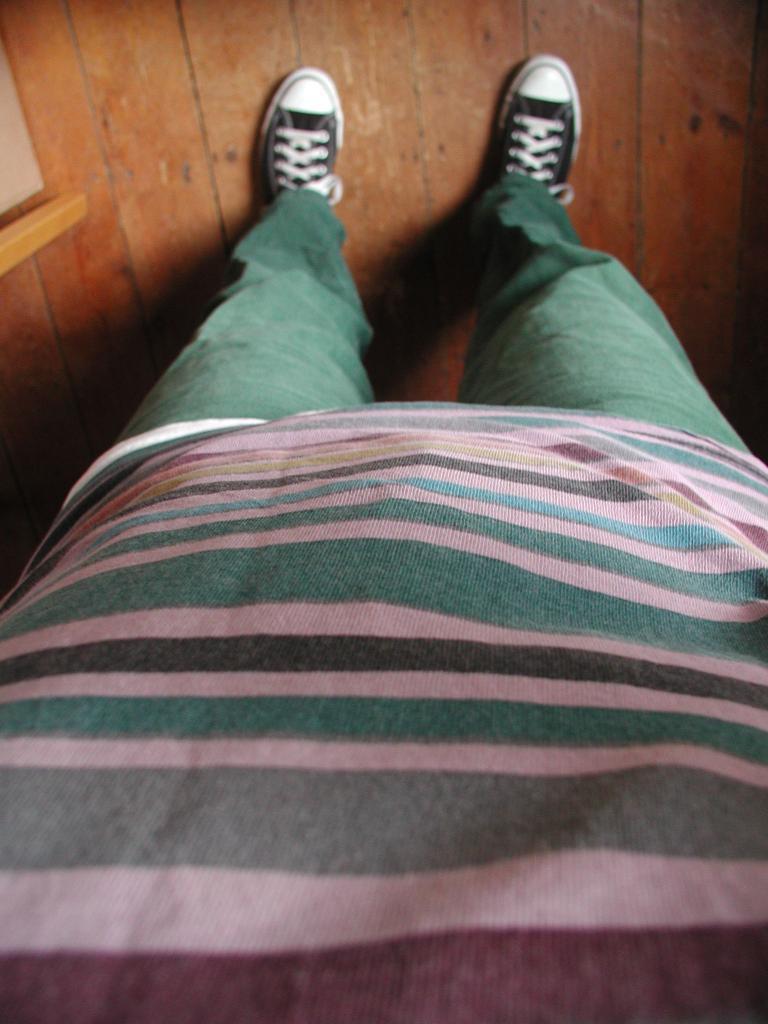Please provide a concise description of this image. In this picture I can see there is a person standing and he is wearing a t-shirt and a green pant and a pair of black shoes and the floor is made of wood. 